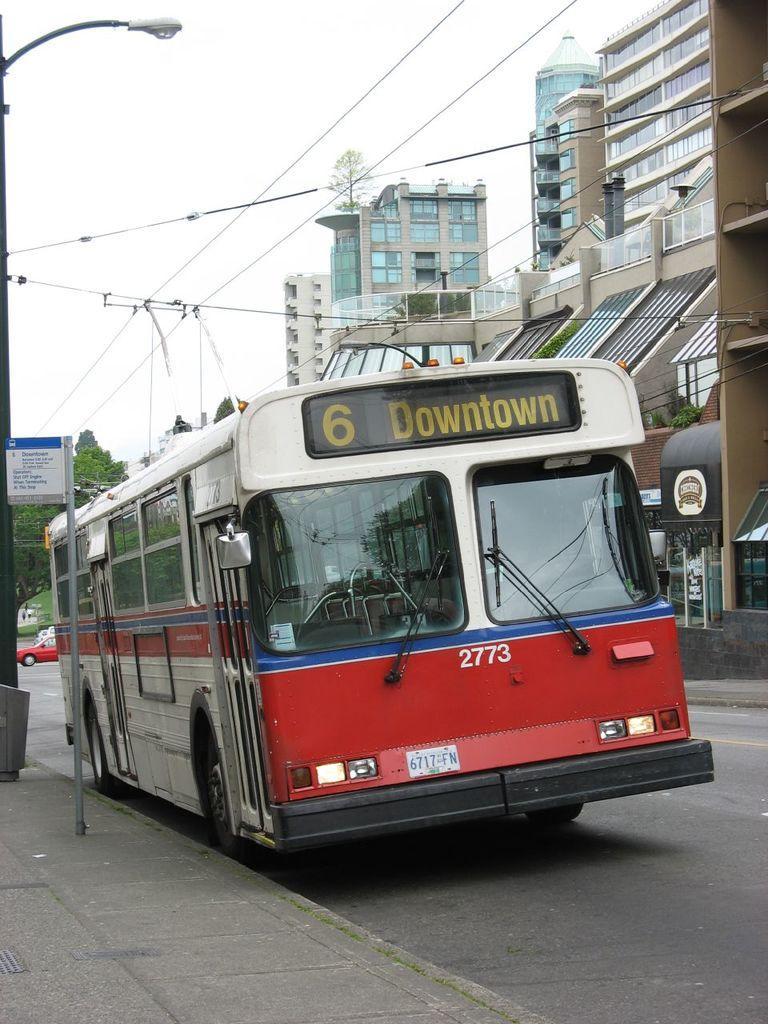What is the main subject of the image? There is a vehicle in the image. What can be seen on the vehicle? There is text written on the vehicle. What else is visible in the image besides the vehicle? There are buildings, light poles, and trees in the image. Is there any textual information present in the image other than the text on the vehicle? Yes, there is a board with text in the image. Can you see any cobwebs on the light poles in the image? There is no mention of cobwebs in the provided facts, so we cannot determine if any are present in the image. What type of fuel is being used by the vehicle in the image? The provided facts do not mention the type of fuel being used by the vehicle, so we cannot determine this information from the image. 